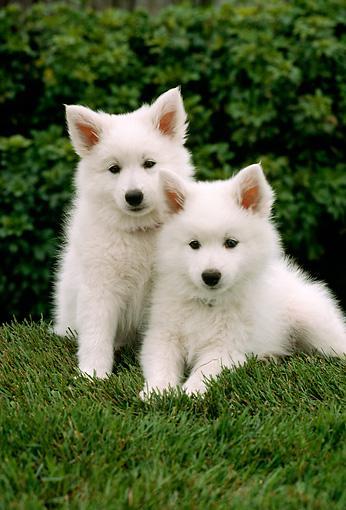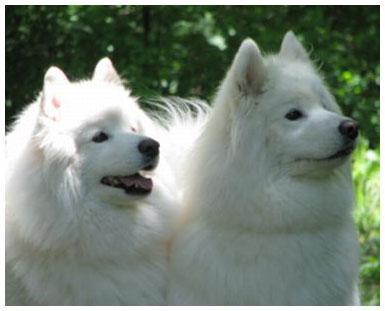The first image is the image on the left, the second image is the image on the right. Assess this claim about the two images: "All dogs face the same direction, and all dogs are standing on all fours.". Correct or not? Answer yes or no. No. The first image is the image on the left, the second image is the image on the right. Evaluate the accuracy of this statement regarding the images: "At least one dog is lying down in the image on the left.". Is it true? Answer yes or no. Yes. 